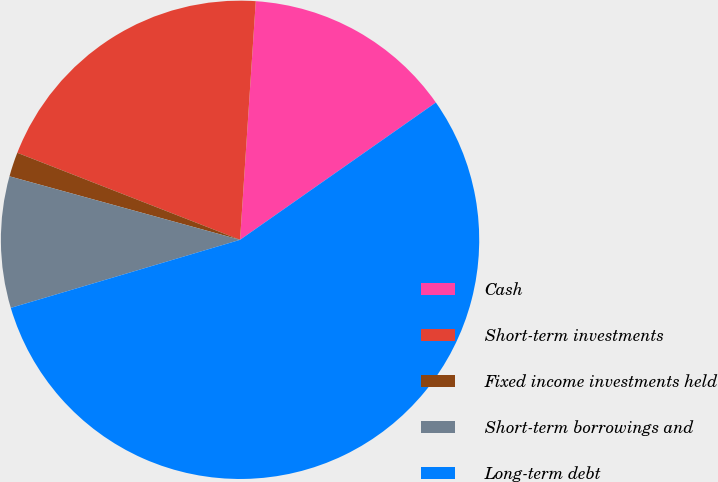Convert chart to OTSL. <chart><loc_0><loc_0><loc_500><loc_500><pie_chart><fcel>Cash<fcel>Short-term investments<fcel>Fixed income investments held<fcel>Short-term borrowings and<fcel>Long-term debt<nl><fcel>14.22%<fcel>20.12%<fcel>1.65%<fcel>8.87%<fcel>55.14%<nl></chart> 